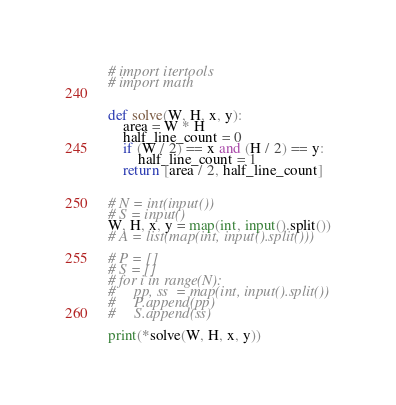<code> <loc_0><loc_0><loc_500><loc_500><_Python_># import itertools
# import math


def solve(W, H, x, y):
    area = W * H
    half_line_count = 0
    if (W / 2) == x and (H / 2) == y:
        half_line_count = 1
    return [area / 2, half_line_count]


# N = int(input())
# S = input()
W, H, x, y = map(int, input().split())
# A = list(map(int, input().split()))

# P = []
# S = []
# for i in range(N):
#     pp, ss  = map(int, input().split())
#     P.append(pp)
#     S.append(ss)

print(*solve(W, H, x, y))
</code> 